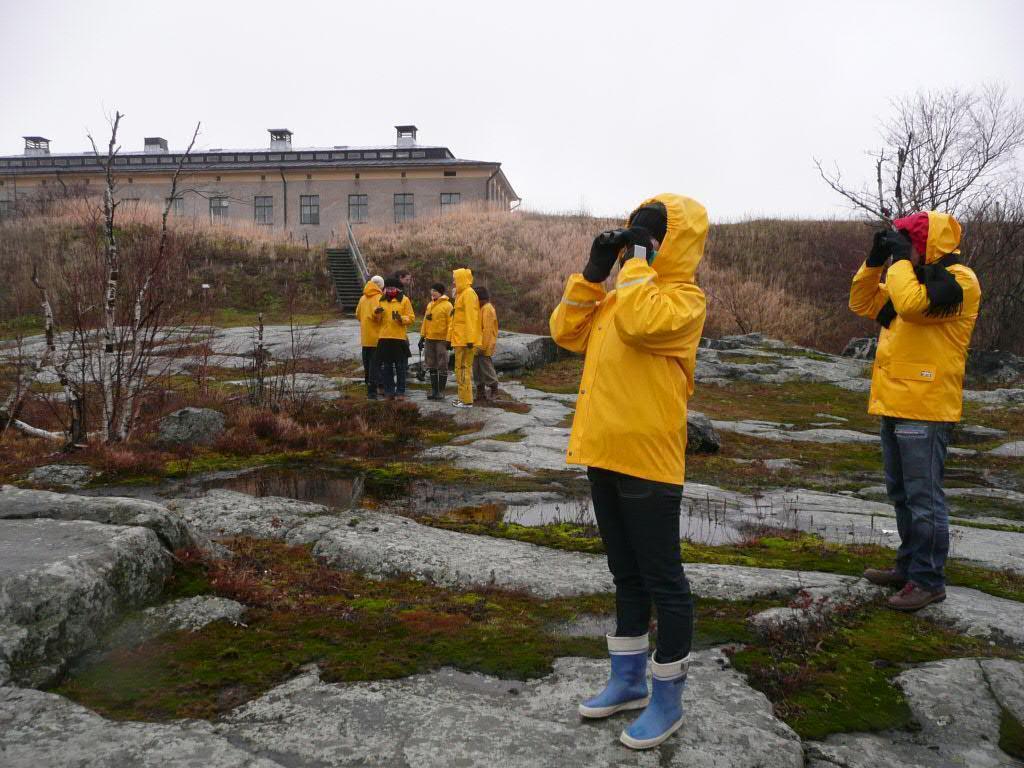How would you summarize this image in a sentence or two? People are standing wearing yellow jackets. There are plants and a building is present at the left back. 